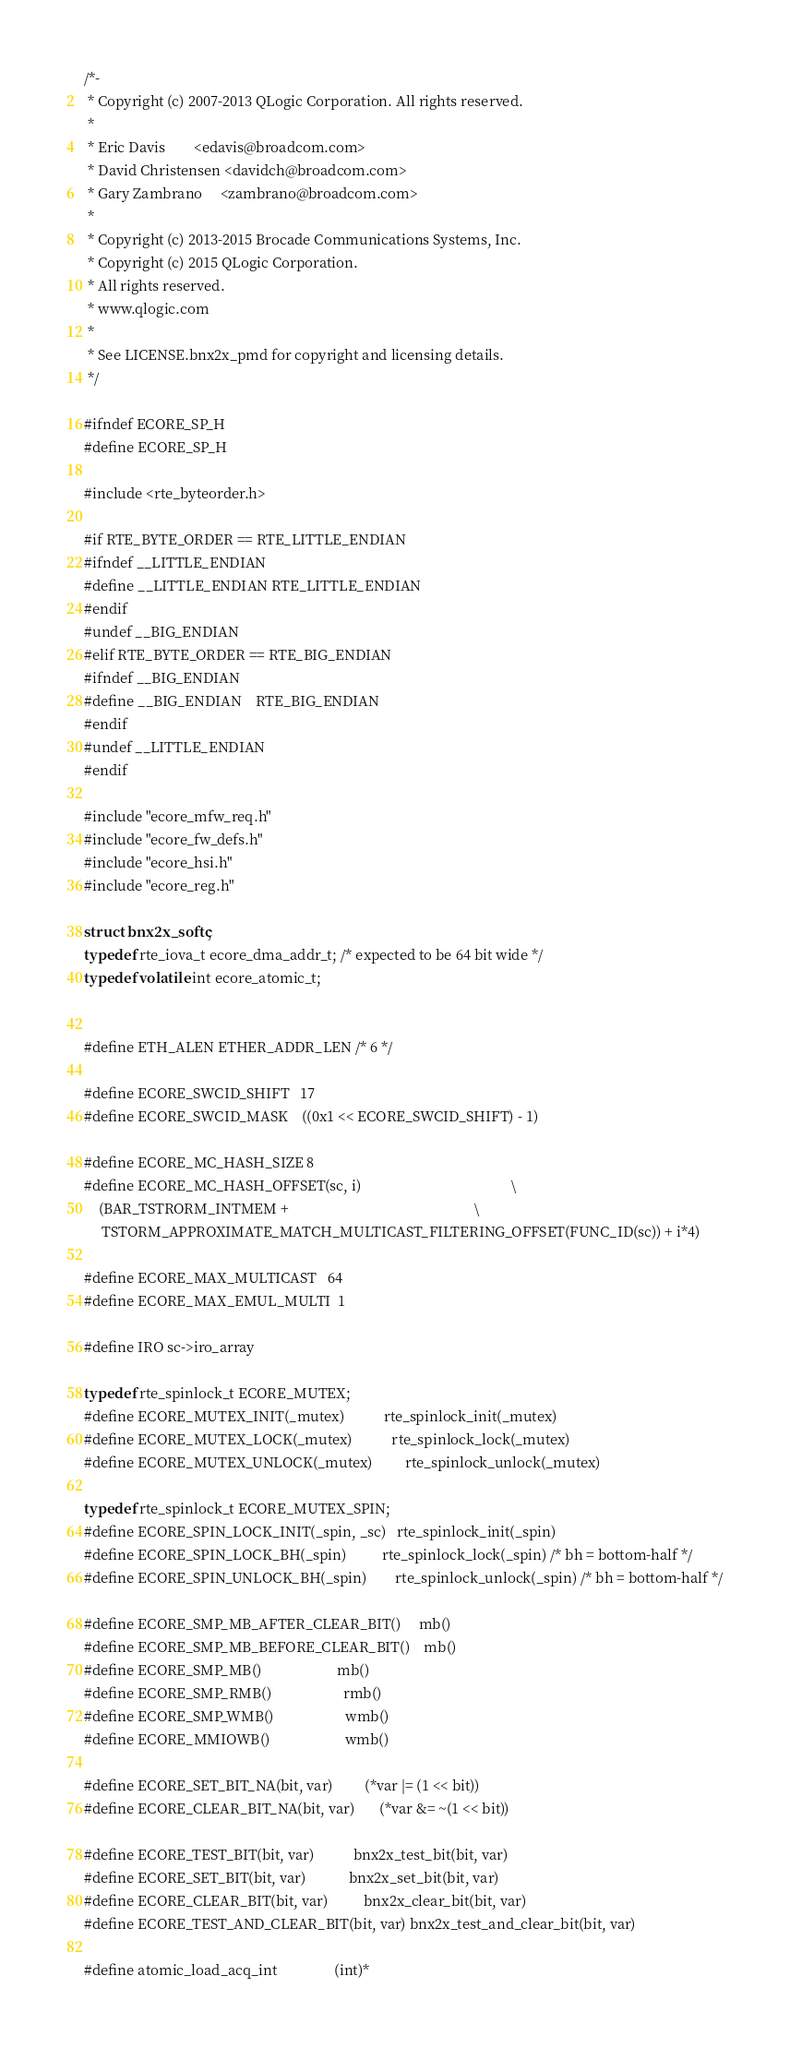<code> <loc_0><loc_0><loc_500><loc_500><_C_>/*-
 * Copyright (c) 2007-2013 QLogic Corporation. All rights reserved.
 *
 * Eric Davis        <edavis@broadcom.com>
 * David Christensen <davidch@broadcom.com>
 * Gary Zambrano     <zambrano@broadcom.com>
 *
 * Copyright (c) 2013-2015 Brocade Communications Systems, Inc.
 * Copyright (c) 2015 QLogic Corporation.
 * All rights reserved.
 * www.qlogic.com
 *
 * See LICENSE.bnx2x_pmd for copyright and licensing details.
 */

#ifndef ECORE_SP_H
#define ECORE_SP_H

#include <rte_byteorder.h>

#if RTE_BYTE_ORDER == RTE_LITTLE_ENDIAN
#ifndef __LITTLE_ENDIAN
#define __LITTLE_ENDIAN RTE_LITTLE_ENDIAN
#endif
#undef __BIG_ENDIAN
#elif RTE_BYTE_ORDER == RTE_BIG_ENDIAN
#ifndef __BIG_ENDIAN
#define __BIG_ENDIAN    RTE_BIG_ENDIAN
#endif
#undef __LITTLE_ENDIAN
#endif

#include "ecore_mfw_req.h"
#include "ecore_fw_defs.h"
#include "ecore_hsi.h"
#include "ecore_reg.h"

struct bnx2x_softc;
typedef rte_iova_t ecore_dma_addr_t; /* expected to be 64 bit wide */
typedef volatile int ecore_atomic_t;


#define ETH_ALEN ETHER_ADDR_LEN /* 6 */

#define ECORE_SWCID_SHIFT   17
#define ECORE_SWCID_MASK    ((0x1 << ECORE_SWCID_SHIFT) - 1)

#define ECORE_MC_HASH_SIZE 8
#define ECORE_MC_HASH_OFFSET(sc, i)                                          \
    (BAR_TSTRORM_INTMEM +                                                    \
     TSTORM_APPROXIMATE_MATCH_MULTICAST_FILTERING_OFFSET(FUNC_ID(sc)) + i*4)

#define ECORE_MAX_MULTICAST   64
#define ECORE_MAX_EMUL_MULTI  1

#define IRO sc->iro_array

typedef rte_spinlock_t ECORE_MUTEX;
#define ECORE_MUTEX_INIT(_mutex)           rte_spinlock_init(_mutex)
#define ECORE_MUTEX_LOCK(_mutex)           rte_spinlock_lock(_mutex)
#define ECORE_MUTEX_UNLOCK(_mutex)         rte_spinlock_unlock(_mutex)

typedef rte_spinlock_t ECORE_MUTEX_SPIN;
#define ECORE_SPIN_LOCK_INIT(_spin, _sc)   rte_spinlock_init(_spin)
#define ECORE_SPIN_LOCK_BH(_spin)          rte_spinlock_lock(_spin) /* bh = bottom-half */
#define ECORE_SPIN_UNLOCK_BH(_spin)        rte_spinlock_unlock(_spin) /* bh = bottom-half */

#define ECORE_SMP_MB_AFTER_CLEAR_BIT()     mb()
#define ECORE_SMP_MB_BEFORE_CLEAR_BIT()    mb()
#define ECORE_SMP_MB()                     mb()
#define ECORE_SMP_RMB()                    rmb()
#define ECORE_SMP_WMB()                    wmb()
#define ECORE_MMIOWB()                     wmb()

#define ECORE_SET_BIT_NA(bit, var)         (*var |= (1 << bit))
#define ECORE_CLEAR_BIT_NA(bit, var)       (*var &= ~(1 << bit))

#define ECORE_TEST_BIT(bit, var)           bnx2x_test_bit(bit, var)
#define ECORE_SET_BIT(bit, var)            bnx2x_set_bit(bit, var)
#define ECORE_CLEAR_BIT(bit, var)          bnx2x_clear_bit(bit, var)
#define ECORE_TEST_AND_CLEAR_BIT(bit, var) bnx2x_test_and_clear_bit(bit, var)

#define atomic_load_acq_int                (int)*</code> 